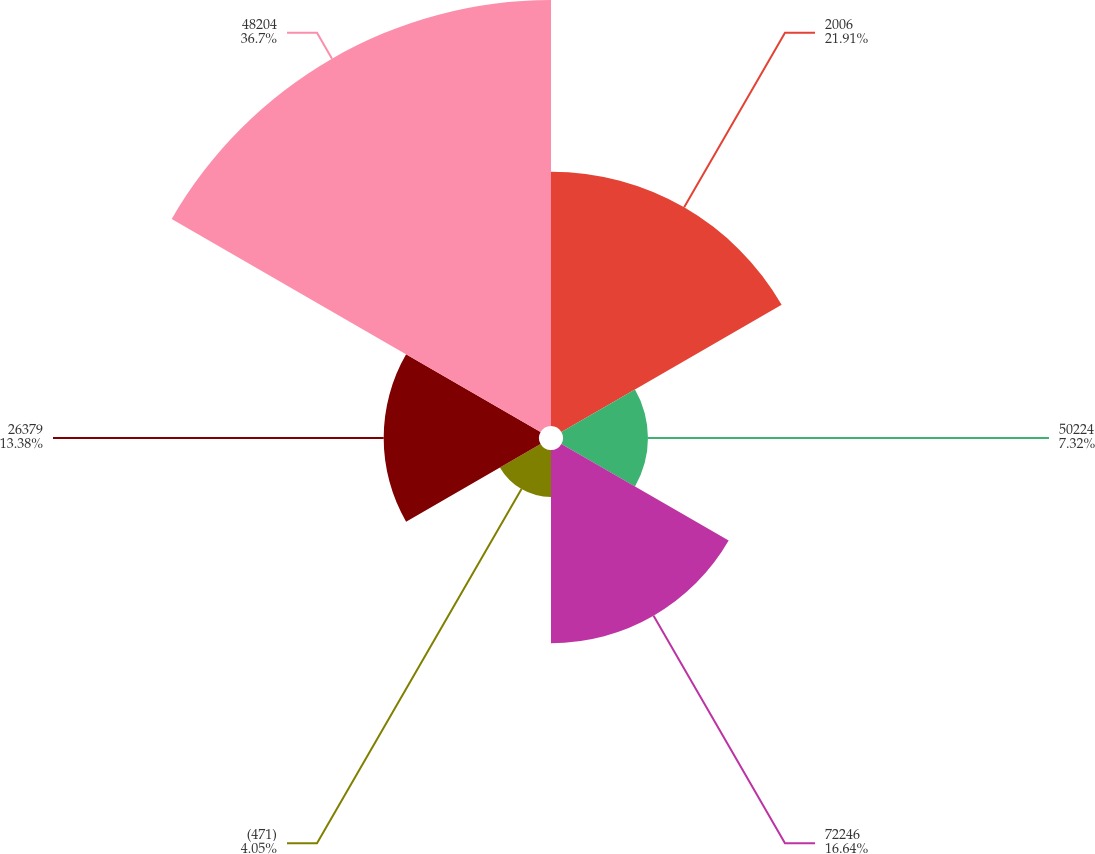Convert chart. <chart><loc_0><loc_0><loc_500><loc_500><pie_chart><fcel>2006<fcel>50224<fcel>72246<fcel>(471)<fcel>26379<fcel>48204<nl><fcel>21.91%<fcel>7.32%<fcel>16.64%<fcel>4.05%<fcel>13.38%<fcel>36.7%<nl></chart> 